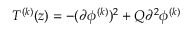Convert formula to latex. <formula><loc_0><loc_0><loc_500><loc_500>T ^ { ( k ) } ( z ) = - ( \partial \phi ^ { ( k ) } ) ^ { 2 } + Q \partial ^ { 2 } \phi ^ { ( k ) }</formula> 